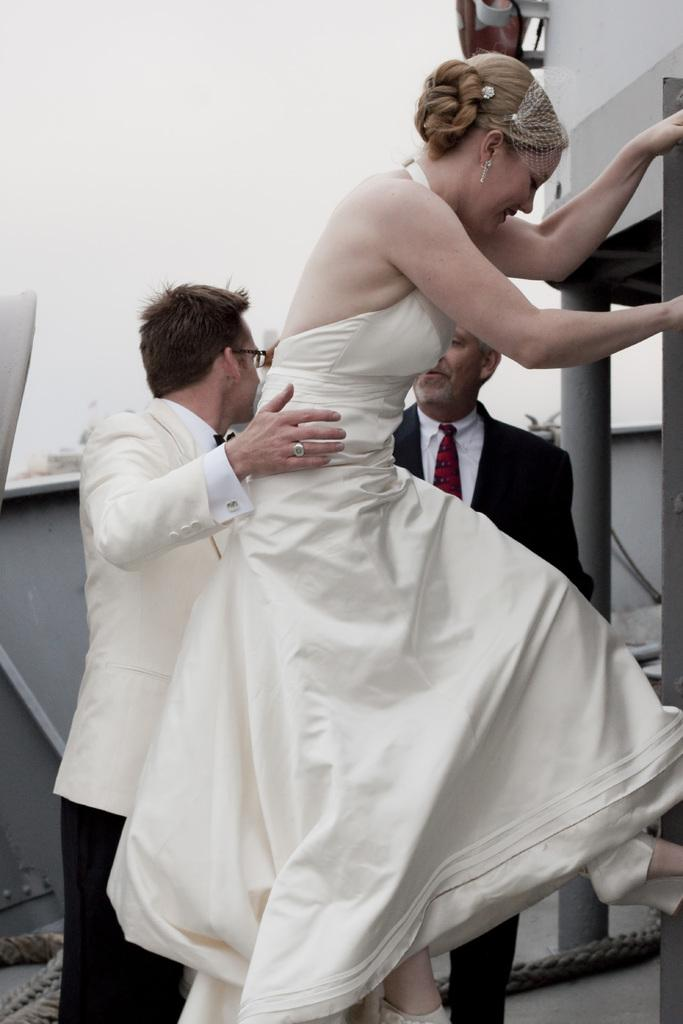How many people are present in the image? There are three people in the image. Can you describe the clothing of one of the women in the image? One woman is wearing a white dress. What type of suit is one of the men wearing? One man is wearing a white suit. How is the other man dressed in the image? The other man is wearing a black suit and tie. What type of seed is being planted by the man in the image? There is no man planting seeds in the image; the image features three people dressed in different outfits. What book is the woman reading in the image? There is no woman reading a book in the image; the image focuses on the clothing of the three people. 